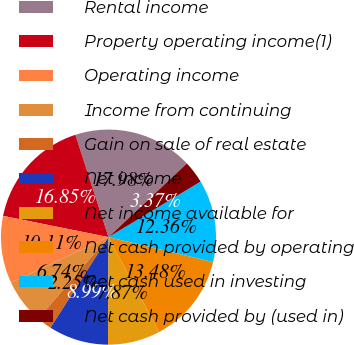<chart> <loc_0><loc_0><loc_500><loc_500><pie_chart><fcel>Rental income<fcel>Property operating income(1)<fcel>Operating income<fcel>Income from continuing<fcel>Gain on sale of real estate<fcel>Net income<fcel>Net income available for<fcel>Net cash provided by operating<fcel>Net cash used in investing<fcel>Net cash provided by (used in)<nl><fcel>17.98%<fcel>16.85%<fcel>10.11%<fcel>6.74%<fcel>2.25%<fcel>8.99%<fcel>7.87%<fcel>13.48%<fcel>12.36%<fcel>3.37%<nl></chart> 